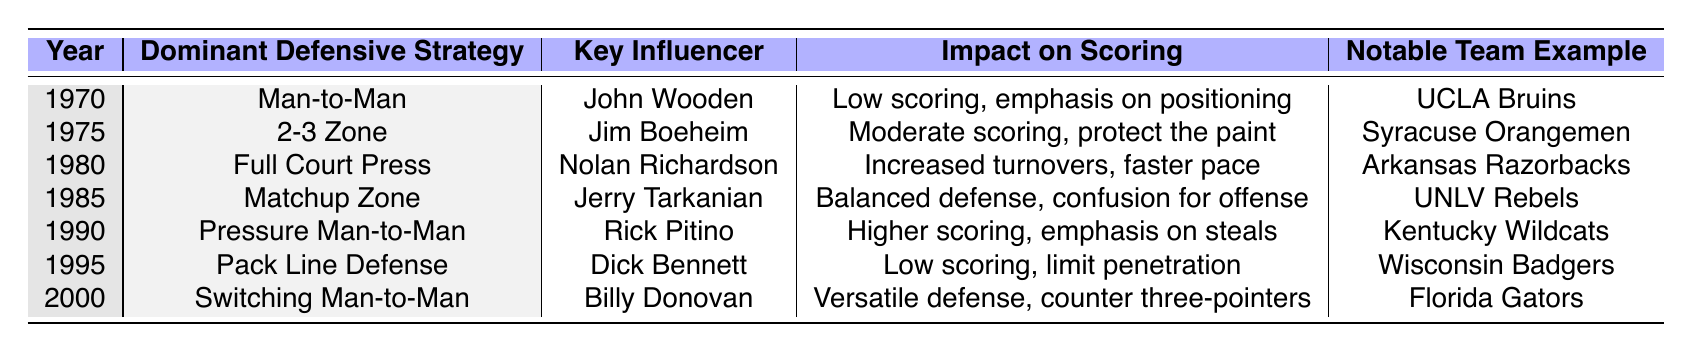What was the dominant defensive strategy in 1980? By referring to the row for the year 1980, we see that the dominant defensive strategy listed is "Full Court Press."
Answer: Full Court Press Which team is noted for using the 2-3 Zone? Looking at the row for the year 1975, we find that the "Notable Team Example" associated with the 2-3 Zone is "Syracuse Orangemen."
Answer: Syracuse Orangemen What key influence shaped the defensive strategies in college basketball in 1990? By examining the row for the year 1990, we find that "Rick Pitino" is listed as the key influencer for that time period.
Answer: Rick Pitino What impact did the 1985 defensive strategy have on scoring? The row for the year 1985 indicates that the "Impact on Scoring" for the Matchup Zone was "Balanced defense, confusion for offense."
Answer: Balanced defense, confusion Was the dominant defensive strategy in 1995 focused on high scoring? In 1995, the dominant defensive strategy was the Pack Line Defense, which is associated with "Low scoring, limit penetration." This indicates a focus on defense rather than high scoring.
Answer: No Which two years had low scoring impacts, according to the table? Looking at the years 1970 and 1995, we see both have "Low scoring" impacts listed. Therefore, these two years have low scoring impacts.
Answer: 1970 and 1995 What change occurred in defensive strategies from 1980 to 1990? In 1980, the defensive strategy was the Full Court Press, which led to "Increased turnovers, faster pace." By 1990, the strategy evolved to Pressure Man-to-Man, which emphasized "Higher scoring, emphasis on steals." This shows a shift from a faster-paced game with turnovers to prioritizing steals.
Answer: Shift from Full Court Press to Pressure Man-to-Man with focus on steals In which year did the Switching Man-to-Man defense become dominant, and what was its impact? The Switching Man-to-Man defense became dominant in the year 2000, with its "Impact on Scoring" described as a "Versatile defense, counter three-pointers."
Answer: 2000; versatile defense, counter three-pointers Who was the key influencer associated with the Matchup Zone, and what was the notable impact? The key influencer for the Matchup Zone in 1985 was "Jerry Tarkanian," and the notable impact was a "Balanced defense, confusion for offense."
Answer: Jerry Tarkanian; balanced defense, confusion Identify the defensive strategy that had the highest impact on scoring and explain why. The strategy with the highest impact on scoring is the Pressure Man-to-Man in 1990, indicated by "Higher scoring, emphasis on steals." This shows a strategic intention to not only defend but also to create scoring opportunities.
Answer: Pressure Man-to-Man in 1990; higher scoring, emphasis on steals 